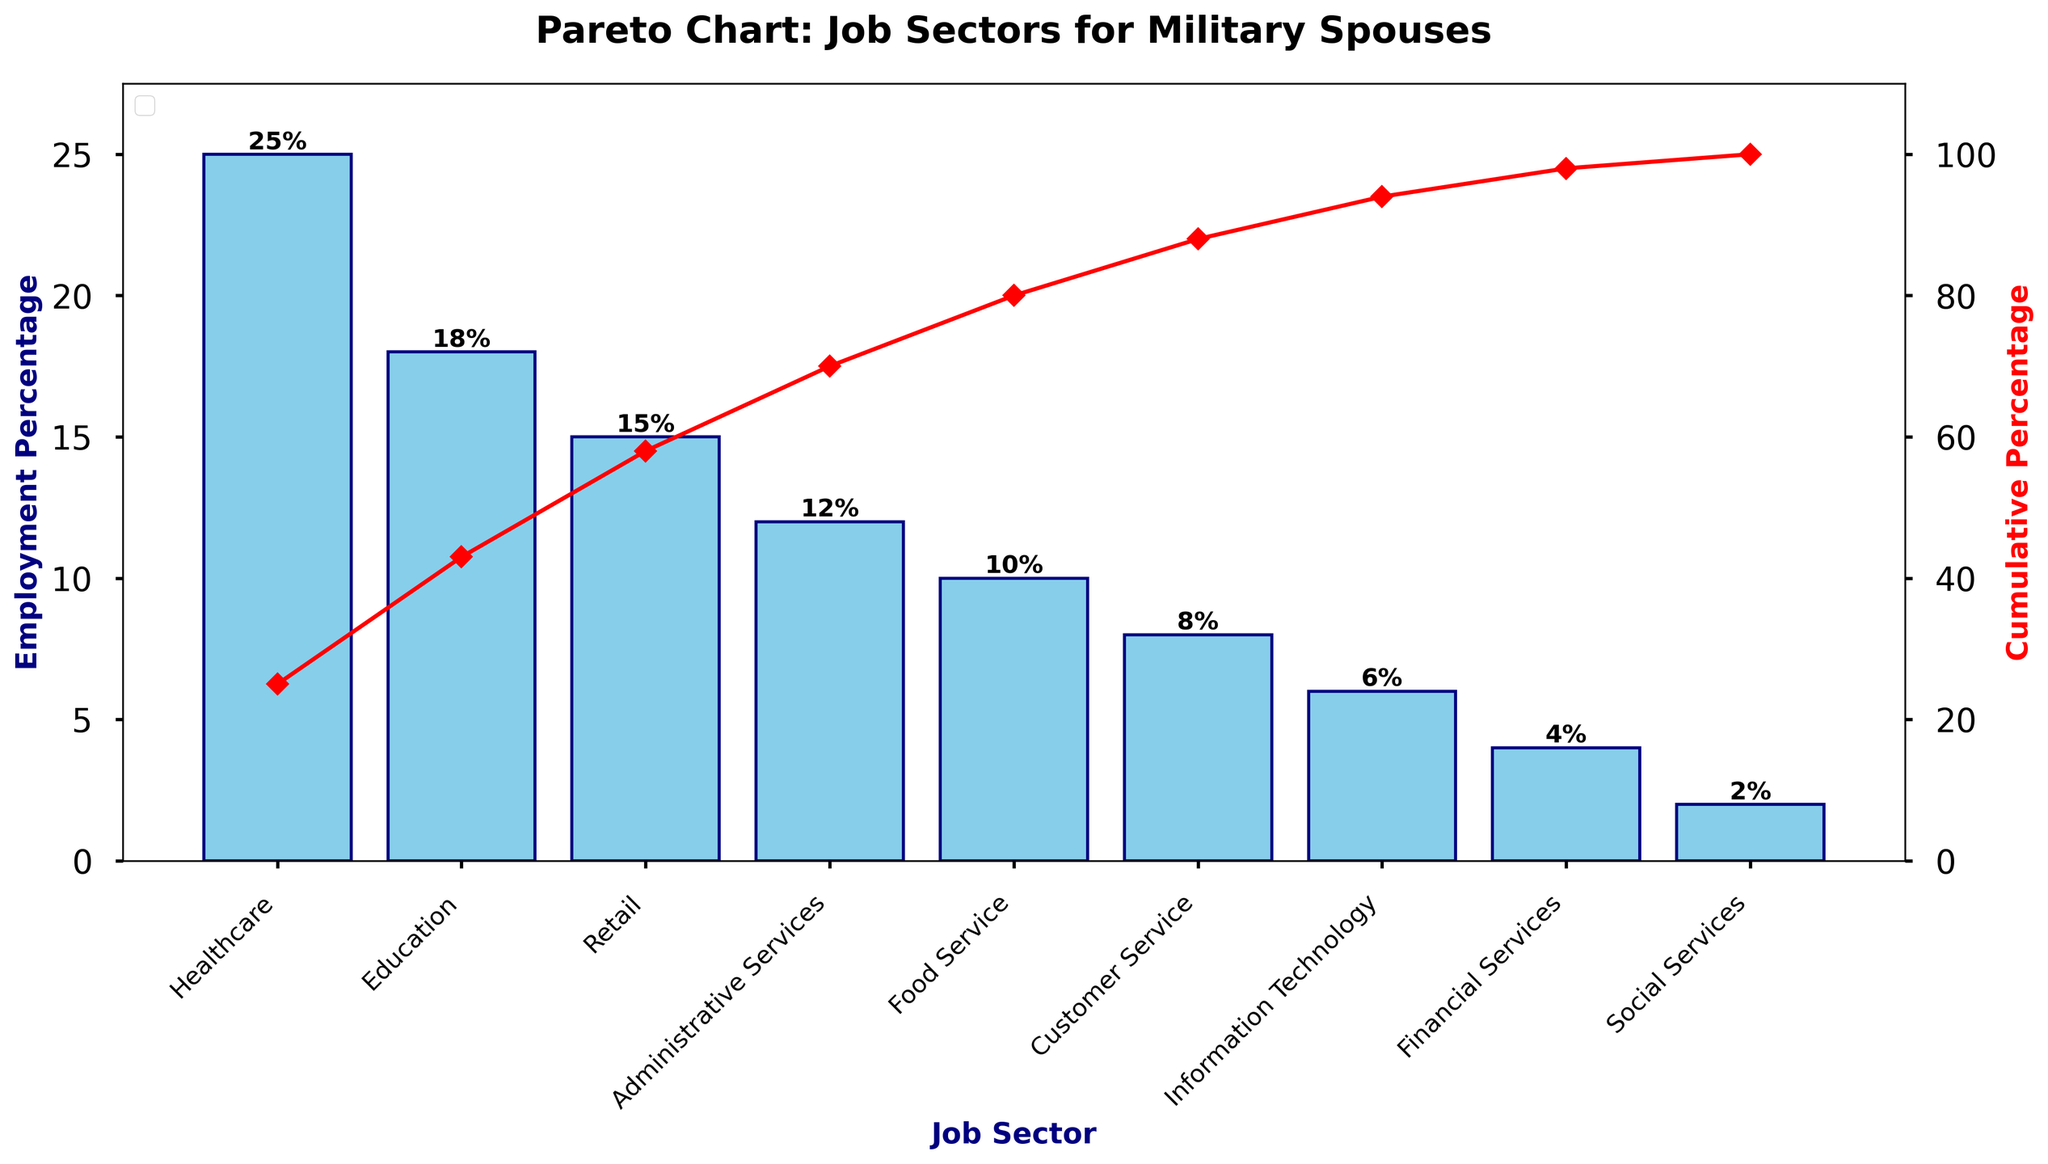What's the title of the figure? The title is usually placed at the top of a figure and summarizes its content briefly. In this case, the title is "Pareto Chart: Job Sectors for Military Spouses".
Answer: Pareto Chart: Job Sectors for Military Spouses Which job sector has the highest employment percentage? The highest bar in the Pareto chart represents the job sector with the highest employment percentage. This is the Healthcare sector.
Answer: Healthcare What is the employment percentage of the Food Service sector? Locate the bar corresponding to the Food Service sector on the x-axis and read its height. It shows that the employment percentage is 10%.
Answer: 10% What is the cumulative percentage after including the top three job sectors? The cumulative percentage line indicates the sum of employment percentages up to a given sector. For Healthcare, Education, and Retail, the cumulative percentage reaches 58%.
Answer: 58% Which sectors fall below the cumulative 80% threshold? The Pareto principle indicates that a few categories account for the majority of the effect. Locate the point where the cumulative percentage exceeds 80%. The sectors below this threshold are Healthcare, Education, Retail, Administrative Services, and Food Service.
Answer: Healthcare, Education, Retail, Administrative Services, Food Service What percentage of military spouses are employed in Information Technology? Locate the bar for Information Technology on the x-axis and read its height to find the employment percentage. It is 6%.
Answer: 6% Compare the combined employment percentage of Education and Retail sectors. Which has a greater percentage? Sum the percentage of the Education sector (18%) and Retail sector (15%), then compare them. The combined total is 33%. Education alone has a greater percentage than Retail.
Answer: Education What is the difference in employment percentage between Administrative Services and Customer Service? Subtract the employment percentage of Customer Service (8%) from that of Administrative Services (12%). The difference is 4%.
Answer: 4% How many job sectors are featured in the chart? Count the number of bars representing different job sectors on the x-axis. There are 9 job sectors in total.
Answer: 9 What is the cumulative percentage for the sectors combining Social Services, Information Technology, and Customer Service? Sum the individual percentages of Social Services (2%), Information Technology (6%), and Customer Service (8%), then refer to the cumulative percentage line or calculate. The combined total is 16%.
Answer: 16% 